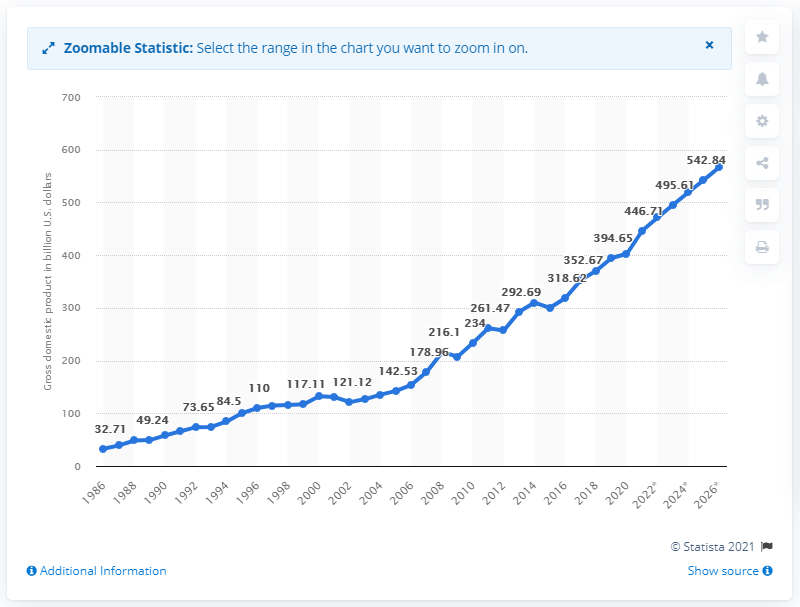Give some essential details in this illustration. In 2020, the gross domestic product of Israel was 402.64 billion dollars. 